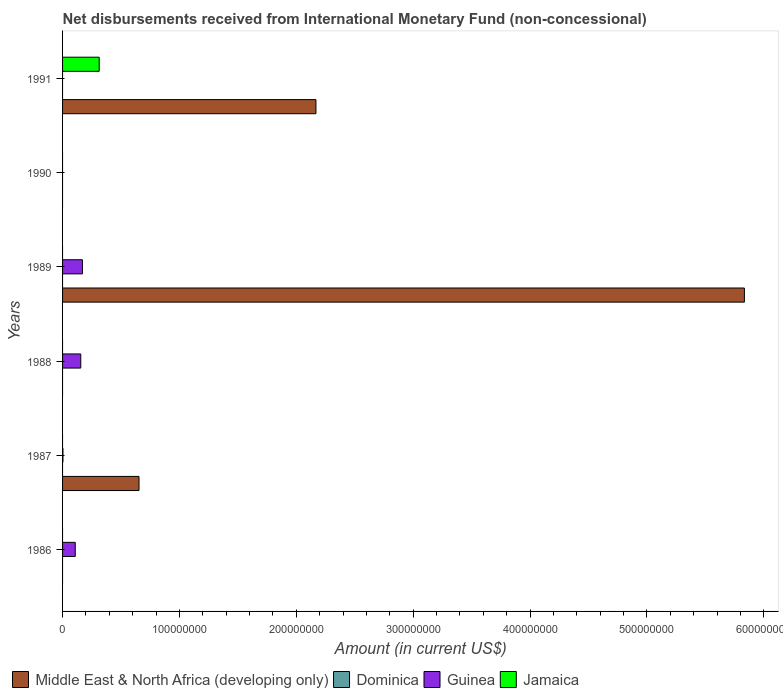Are the number of bars per tick equal to the number of legend labels?
Your answer should be compact. No. How many bars are there on the 6th tick from the top?
Your response must be concise. 1. How many bars are there on the 3rd tick from the bottom?
Your answer should be compact. 1. What is the label of the 2nd group of bars from the top?
Your answer should be very brief. 1990. In how many cases, is the number of bars for a given year not equal to the number of legend labels?
Offer a terse response. 6. Across all years, what is the maximum amount of disbursements received from International Monetary Fund in Guinea?
Ensure brevity in your answer.  1.70e+07. Across all years, what is the minimum amount of disbursements received from International Monetary Fund in Jamaica?
Offer a terse response. 0. What is the total amount of disbursements received from International Monetary Fund in Middle East & North Africa (developing only) in the graph?
Provide a short and direct response. 8.66e+08. What is the difference between the amount of disbursements received from International Monetary Fund in Guinea in 1988 and that in 1989?
Provide a succinct answer. -1.41e+06. What is the average amount of disbursements received from International Monetary Fund in Guinea per year?
Your answer should be very brief. 7.29e+06. Is the amount of disbursements received from International Monetary Fund in Guinea in 1986 less than that in 1989?
Your response must be concise. Yes. What is the difference between the highest and the lowest amount of disbursements received from International Monetary Fund in Middle East & North Africa (developing only)?
Make the answer very short. 5.83e+08. In how many years, is the amount of disbursements received from International Monetary Fund in Guinea greater than the average amount of disbursements received from International Monetary Fund in Guinea taken over all years?
Your response must be concise. 3. Is it the case that in every year, the sum of the amount of disbursements received from International Monetary Fund in Dominica and amount of disbursements received from International Monetary Fund in Jamaica is greater than the sum of amount of disbursements received from International Monetary Fund in Middle East & North Africa (developing only) and amount of disbursements received from International Monetary Fund in Guinea?
Ensure brevity in your answer.  No. Are all the bars in the graph horizontal?
Give a very brief answer. Yes. How many years are there in the graph?
Give a very brief answer. 6. Are the values on the major ticks of X-axis written in scientific E-notation?
Give a very brief answer. No. Does the graph contain any zero values?
Your answer should be very brief. Yes. Does the graph contain grids?
Ensure brevity in your answer.  No. What is the title of the graph?
Offer a terse response. Net disbursements received from International Monetary Fund (non-concessional). What is the label or title of the X-axis?
Your response must be concise. Amount (in current US$). What is the label or title of the Y-axis?
Offer a very short reply. Years. What is the Amount (in current US$) in Middle East & North Africa (developing only) in 1986?
Make the answer very short. 0. What is the Amount (in current US$) in Guinea in 1986?
Give a very brief answer. 1.08e+07. What is the Amount (in current US$) in Middle East & North Africa (developing only) in 1987?
Make the answer very short. 6.54e+07. What is the Amount (in current US$) in Guinea in 1987?
Provide a succinct answer. 3.28e+05. What is the Amount (in current US$) in Jamaica in 1987?
Offer a very short reply. 0. What is the Amount (in current US$) in Dominica in 1988?
Ensure brevity in your answer.  0. What is the Amount (in current US$) in Guinea in 1988?
Keep it short and to the point. 1.56e+07. What is the Amount (in current US$) of Middle East & North Africa (developing only) in 1989?
Offer a terse response. 5.83e+08. What is the Amount (in current US$) in Guinea in 1989?
Offer a very short reply. 1.70e+07. What is the Amount (in current US$) of Jamaica in 1989?
Offer a very short reply. 0. What is the Amount (in current US$) in Guinea in 1990?
Provide a short and direct response. 0. What is the Amount (in current US$) in Jamaica in 1990?
Your answer should be very brief. 0. What is the Amount (in current US$) in Middle East & North Africa (developing only) in 1991?
Your answer should be compact. 2.17e+08. What is the Amount (in current US$) in Jamaica in 1991?
Your answer should be very brief. 3.13e+07. Across all years, what is the maximum Amount (in current US$) in Middle East & North Africa (developing only)?
Ensure brevity in your answer.  5.83e+08. Across all years, what is the maximum Amount (in current US$) in Guinea?
Provide a succinct answer. 1.70e+07. Across all years, what is the maximum Amount (in current US$) of Jamaica?
Make the answer very short. 3.13e+07. Across all years, what is the minimum Amount (in current US$) of Middle East & North Africa (developing only)?
Provide a short and direct response. 0. Across all years, what is the minimum Amount (in current US$) in Jamaica?
Keep it short and to the point. 0. What is the total Amount (in current US$) of Middle East & North Africa (developing only) in the graph?
Your answer should be compact. 8.66e+08. What is the total Amount (in current US$) of Guinea in the graph?
Your answer should be compact. 4.37e+07. What is the total Amount (in current US$) in Jamaica in the graph?
Offer a terse response. 3.13e+07. What is the difference between the Amount (in current US$) in Guinea in 1986 and that in 1987?
Offer a terse response. 1.05e+07. What is the difference between the Amount (in current US$) in Guinea in 1986 and that in 1988?
Offer a terse response. -4.72e+06. What is the difference between the Amount (in current US$) of Guinea in 1986 and that in 1989?
Give a very brief answer. -6.13e+06. What is the difference between the Amount (in current US$) in Guinea in 1987 and that in 1988?
Keep it short and to the point. -1.52e+07. What is the difference between the Amount (in current US$) in Middle East & North Africa (developing only) in 1987 and that in 1989?
Your answer should be very brief. -5.18e+08. What is the difference between the Amount (in current US$) in Guinea in 1987 and that in 1989?
Give a very brief answer. -1.67e+07. What is the difference between the Amount (in current US$) in Middle East & North Africa (developing only) in 1987 and that in 1991?
Keep it short and to the point. -1.51e+08. What is the difference between the Amount (in current US$) of Guinea in 1988 and that in 1989?
Your answer should be very brief. -1.41e+06. What is the difference between the Amount (in current US$) of Middle East & North Africa (developing only) in 1989 and that in 1991?
Offer a very short reply. 3.67e+08. What is the difference between the Amount (in current US$) in Guinea in 1986 and the Amount (in current US$) in Jamaica in 1991?
Offer a terse response. -2.05e+07. What is the difference between the Amount (in current US$) in Middle East & North Africa (developing only) in 1987 and the Amount (in current US$) in Guinea in 1988?
Your answer should be very brief. 4.98e+07. What is the difference between the Amount (in current US$) in Middle East & North Africa (developing only) in 1987 and the Amount (in current US$) in Guinea in 1989?
Your answer should be compact. 4.84e+07. What is the difference between the Amount (in current US$) in Middle East & North Africa (developing only) in 1987 and the Amount (in current US$) in Jamaica in 1991?
Give a very brief answer. 3.41e+07. What is the difference between the Amount (in current US$) of Guinea in 1987 and the Amount (in current US$) of Jamaica in 1991?
Ensure brevity in your answer.  -3.10e+07. What is the difference between the Amount (in current US$) of Guinea in 1988 and the Amount (in current US$) of Jamaica in 1991?
Offer a very short reply. -1.58e+07. What is the difference between the Amount (in current US$) of Middle East & North Africa (developing only) in 1989 and the Amount (in current US$) of Jamaica in 1991?
Keep it short and to the point. 5.52e+08. What is the difference between the Amount (in current US$) of Guinea in 1989 and the Amount (in current US$) of Jamaica in 1991?
Make the answer very short. -1.44e+07. What is the average Amount (in current US$) of Middle East & North Africa (developing only) per year?
Provide a succinct answer. 1.44e+08. What is the average Amount (in current US$) of Dominica per year?
Provide a succinct answer. 0. What is the average Amount (in current US$) in Guinea per year?
Offer a very short reply. 7.29e+06. What is the average Amount (in current US$) of Jamaica per year?
Offer a very short reply. 5.22e+06. In the year 1987, what is the difference between the Amount (in current US$) of Middle East & North Africa (developing only) and Amount (in current US$) of Guinea?
Your response must be concise. 6.51e+07. In the year 1989, what is the difference between the Amount (in current US$) in Middle East & North Africa (developing only) and Amount (in current US$) in Guinea?
Ensure brevity in your answer.  5.66e+08. In the year 1991, what is the difference between the Amount (in current US$) of Middle East & North Africa (developing only) and Amount (in current US$) of Jamaica?
Provide a succinct answer. 1.85e+08. What is the ratio of the Amount (in current US$) in Guinea in 1986 to that in 1987?
Your answer should be compact. 33.08. What is the ratio of the Amount (in current US$) of Guinea in 1986 to that in 1988?
Offer a terse response. 0.7. What is the ratio of the Amount (in current US$) in Guinea in 1986 to that in 1989?
Provide a short and direct response. 0.64. What is the ratio of the Amount (in current US$) of Guinea in 1987 to that in 1988?
Your answer should be compact. 0.02. What is the ratio of the Amount (in current US$) in Middle East & North Africa (developing only) in 1987 to that in 1989?
Your response must be concise. 0.11. What is the ratio of the Amount (in current US$) in Guinea in 1987 to that in 1989?
Give a very brief answer. 0.02. What is the ratio of the Amount (in current US$) of Middle East & North Africa (developing only) in 1987 to that in 1991?
Give a very brief answer. 0.3. What is the ratio of the Amount (in current US$) of Guinea in 1988 to that in 1989?
Make the answer very short. 0.92. What is the ratio of the Amount (in current US$) of Middle East & North Africa (developing only) in 1989 to that in 1991?
Offer a very short reply. 2.69. What is the difference between the highest and the second highest Amount (in current US$) in Middle East & North Africa (developing only)?
Your response must be concise. 3.67e+08. What is the difference between the highest and the second highest Amount (in current US$) in Guinea?
Make the answer very short. 1.41e+06. What is the difference between the highest and the lowest Amount (in current US$) of Middle East & North Africa (developing only)?
Give a very brief answer. 5.83e+08. What is the difference between the highest and the lowest Amount (in current US$) of Guinea?
Provide a short and direct response. 1.70e+07. What is the difference between the highest and the lowest Amount (in current US$) of Jamaica?
Your answer should be compact. 3.13e+07. 